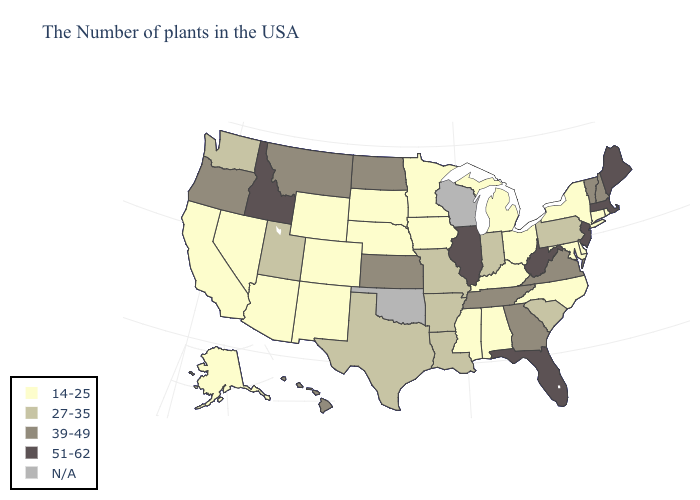Does New York have the lowest value in the Northeast?
Be succinct. Yes. Name the states that have a value in the range 39-49?
Concise answer only. New Hampshire, Vermont, Virginia, Georgia, Tennessee, Kansas, North Dakota, Montana, Oregon, Hawaii. What is the value of Mississippi?
Write a very short answer. 14-25. What is the lowest value in the Northeast?
Be succinct. 14-25. Name the states that have a value in the range 51-62?
Be succinct. Maine, Massachusetts, New Jersey, West Virginia, Florida, Illinois, Idaho. How many symbols are there in the legend?
Be succinct. 5. Name the states that have a value in the range 51-62?
Quick response, please. Maine, Massachusetts, New Jersey, West Virginia, Florida, Illinois, Idaho. Which states have the lowest value in the MidWest?
Answer briefly. Ohio, Michigan, Minnesota, Iowa, Nebraska, South Dakota. What is the highest value in states that border Michigan?
Keep it brief. 27-35. What is the highest value in the USA?
Keep it brief. 51-62. Name the states that have a value in the range N/A?
Write a very short answer. Wisconsin, Oklahoma. Is the legend a continuous bar?
Give a very brief answer. No. What is the value of North Carolina?
Answer briefly. 14-25. Does Tennessee have the lowest value in the South?
Keep it brief. No. 